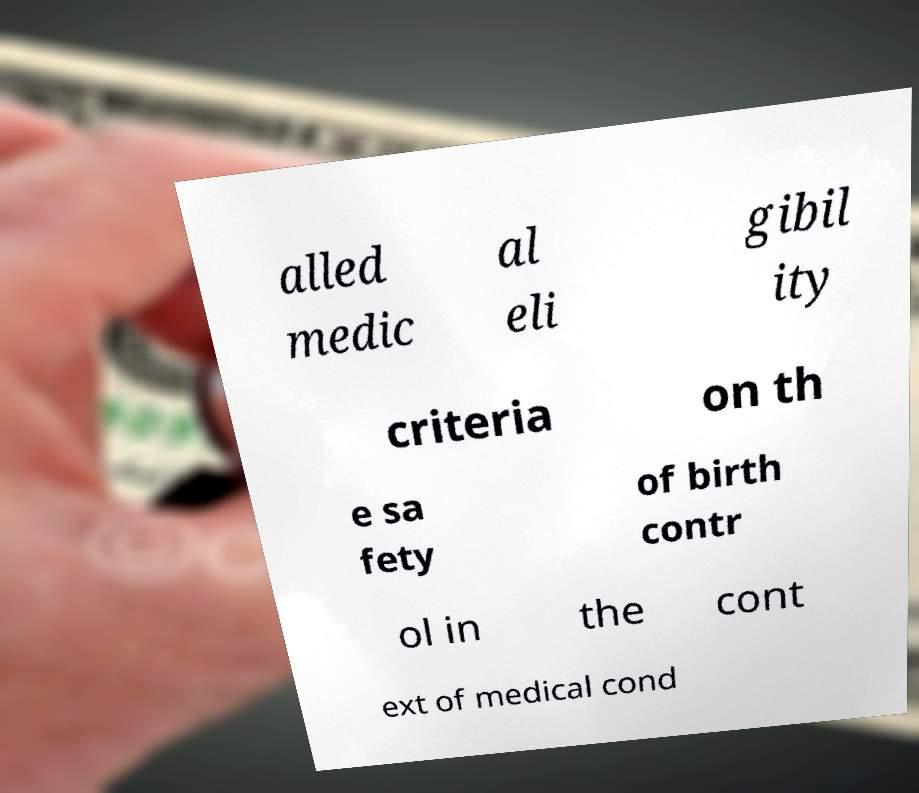Please read and relay the text visible in this image. What does it say? alled medic al eli gibil ity criteria on th e sa fety of birth contr ol in the cont ext of medical cond 